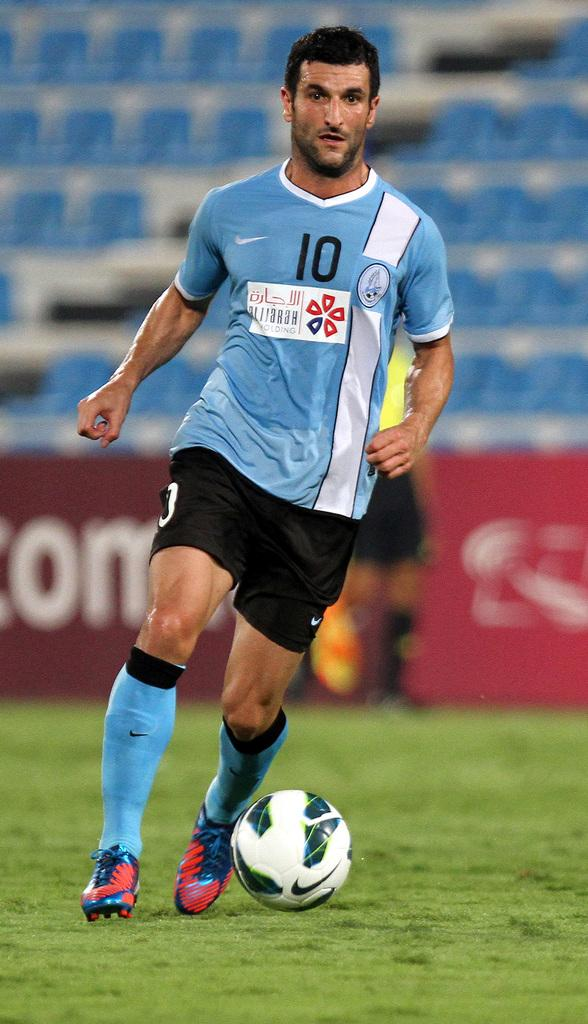<image>
Give a short and clear explanation of the subsequent image. A man in the number 10 jersey runs with a ball. 